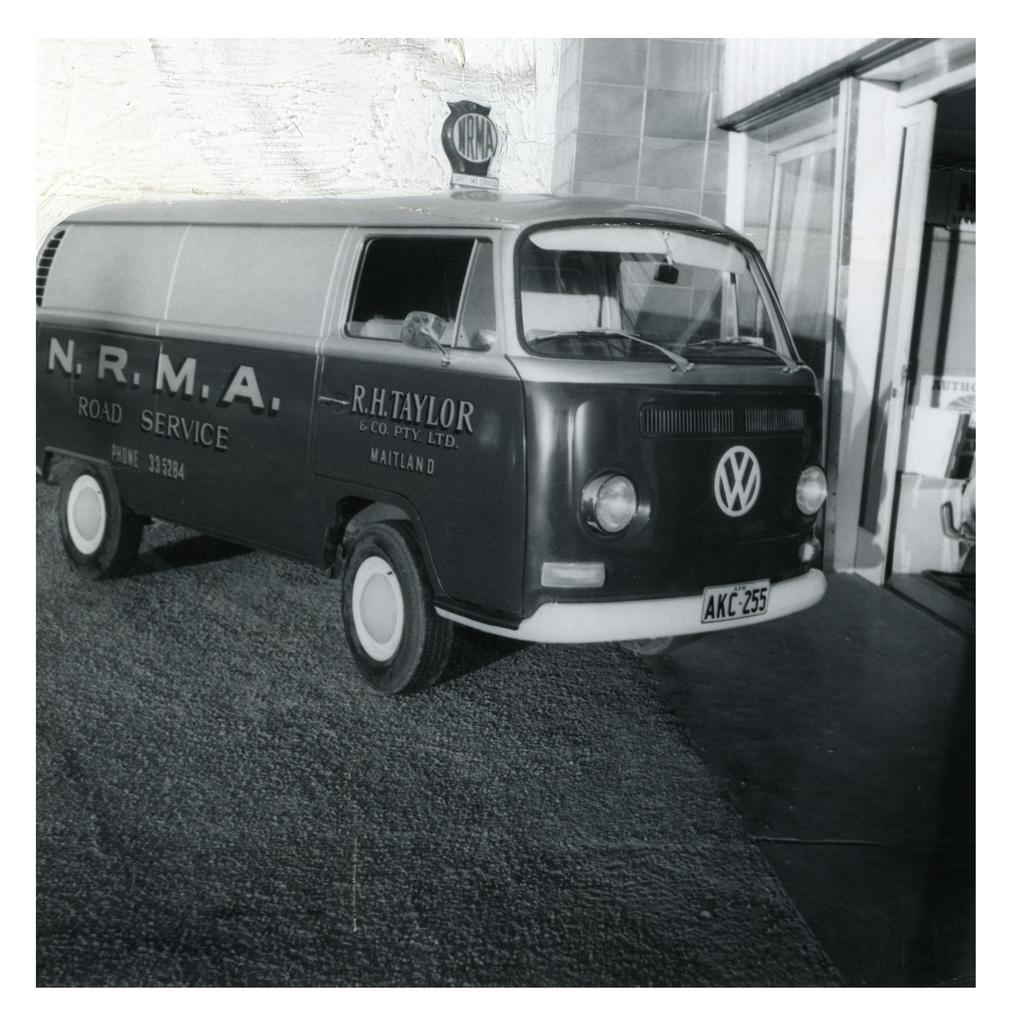What is the color scheme of the image? The image is black and white. What type of structure can be seen in the image? There is a wall in the image. What else is present in the image besides the wall? There is a vehicle, a board, and a glass door in the image. How does the jellyfish interact with the board in the image? There is no jellyfish present in the image, so it cannot interact with the board. 